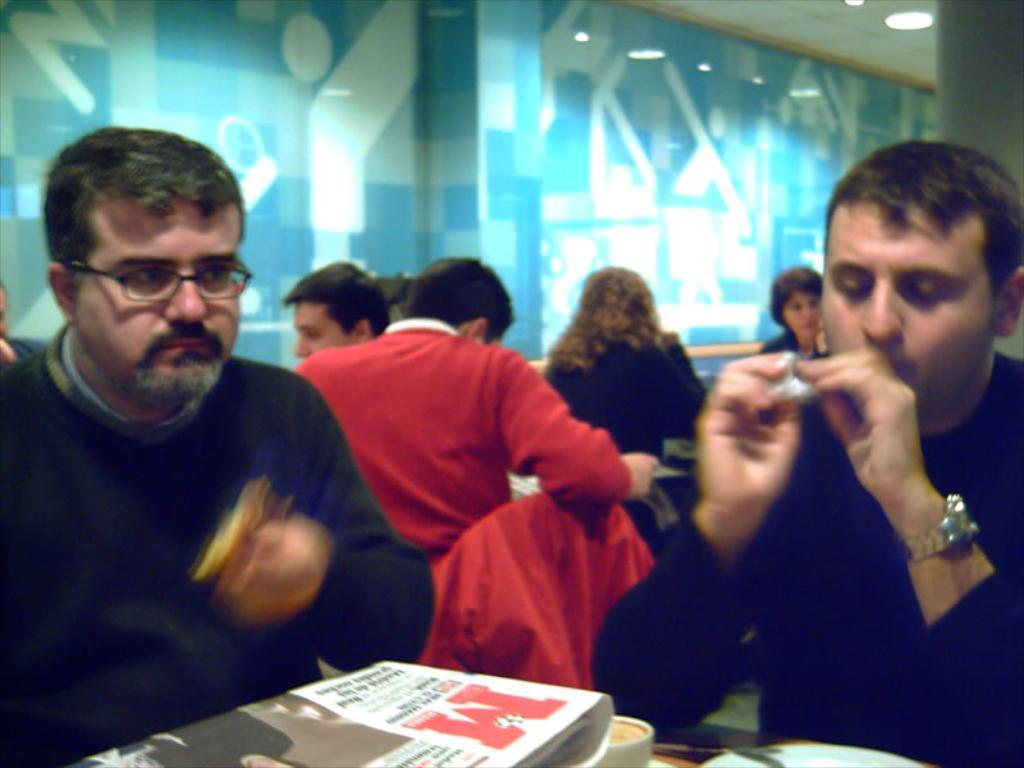What activity are the people in the image engaged in? The people in the image are sitting around a table. What can be seen on the table in the image? There is a coffee cup and a newspaper on the table. What color is the wall in the background of the image? The wall in the background of the image is blue. What type of lighting is present in the image? There are lights over the ceiling in the image. What time of day is it in the image? The time of day cannot be determined from the image, as there are no clues such as sunlight or shadows. How does the hose help the people sitting around the table? There is no hose present in the image, so it cannot help the people sitting around the table. 